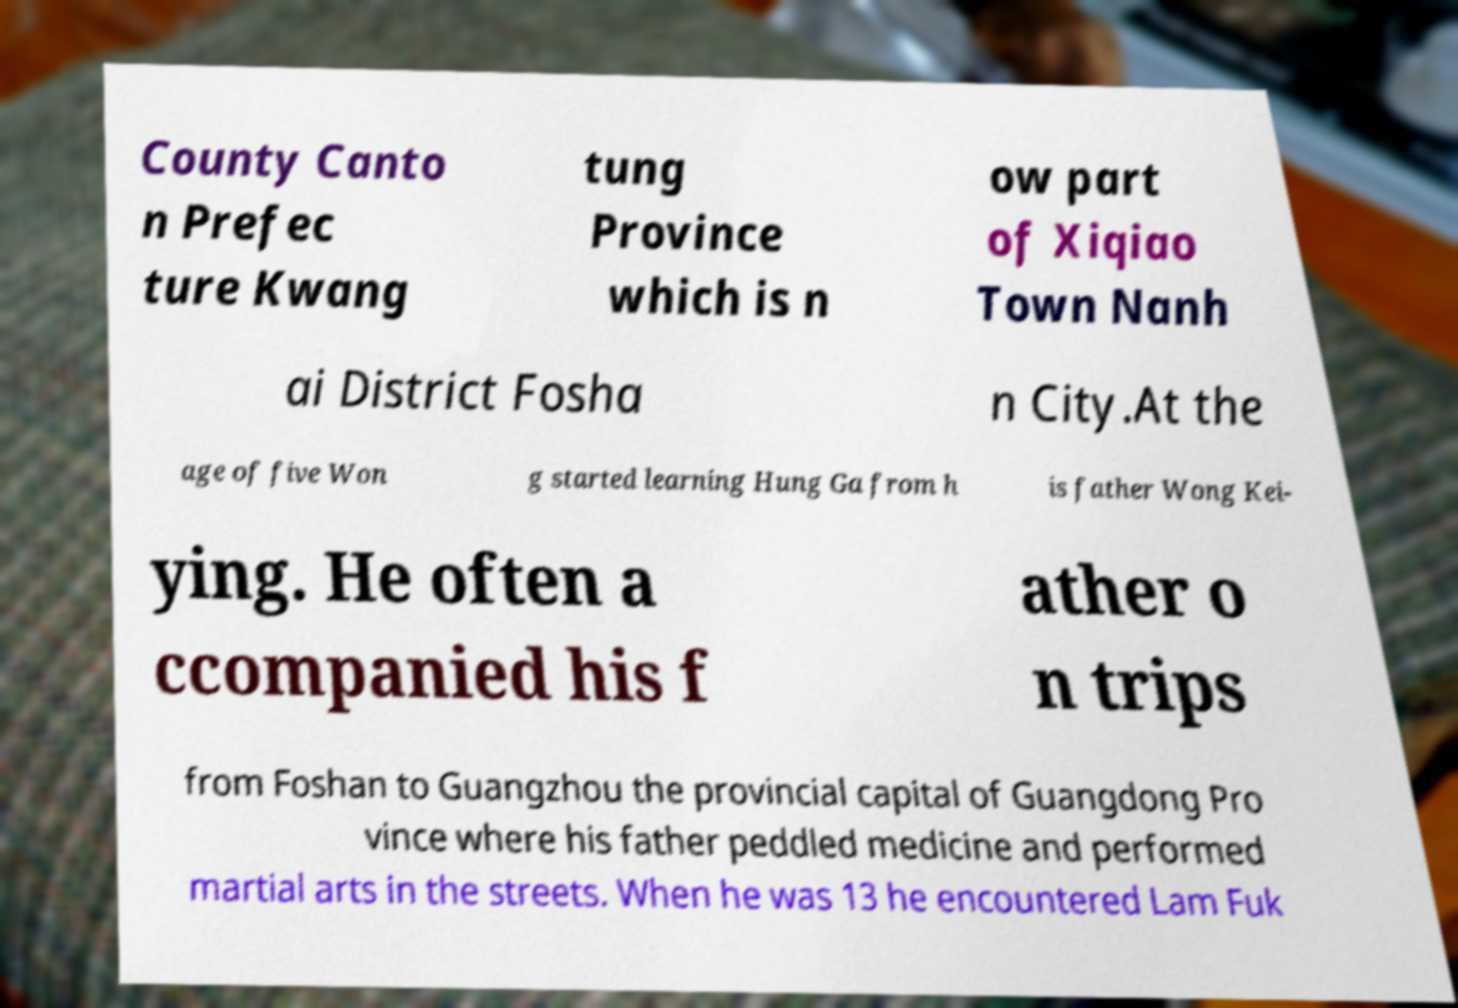What messages or text are displayed in this image? I need them in a readable, typed format. County Canto n Prefec ture Kwang tung Province which is n ow part of Xiqiao Town Nanh ai District Fosha n City.At the age of five Won g started learning Hung Ga from h is father Wong Kei- ying. He often a ccompanied his f ather o n trips from Foshan to Guangzhou the provincial capital of Guangdong Pro vince where his father peddled medicine and performed martial arts in the streets. When he was 13 he encountered Lam Fuk 